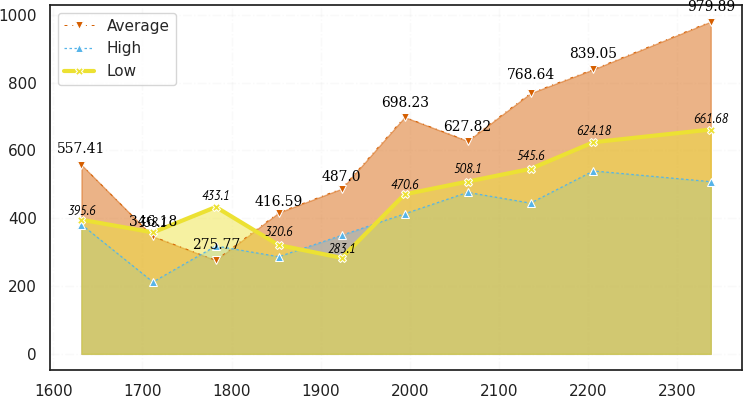Convert chart. <chart><loc_0><loc_0><loc_500><loc_500><line_chart><ecel><fcel>Average<fcel>High<fcel>Low<nl><fcel>1631.62<fcel>557.41<fcel>381.31<fcel>395.6<nl><fcel>1711.79<fcel>346.18<fcel>211.8<fcel>358.1<nl><fcel>1782.38<fcel>275.77<fcel>318.07<fcel>433.1<nl><fcel>1852.97<fcel>416.59<fcel>286.45<fcel>320.6<nl><fcel>1923.56<fcel>487<fcel>349.69<fcel>283.1<nl><fcel>1994.15<fcel>698.23<fcel>412.93<fcel>470.6<nl><fcel>2064.74<fcel>627.82<fcel>476.17<fcel>508.1<nl><fcel>2135.33<fcel>768.64<fcel>444.55<fcel>545.6<nl><fcel>2205.92<fcel>839.05<fcel>539.41<fcel>624.18<nl><fcel>2337.48<fcel>979.89<fcel>507.79<fcel>661.68<nl></chart> 